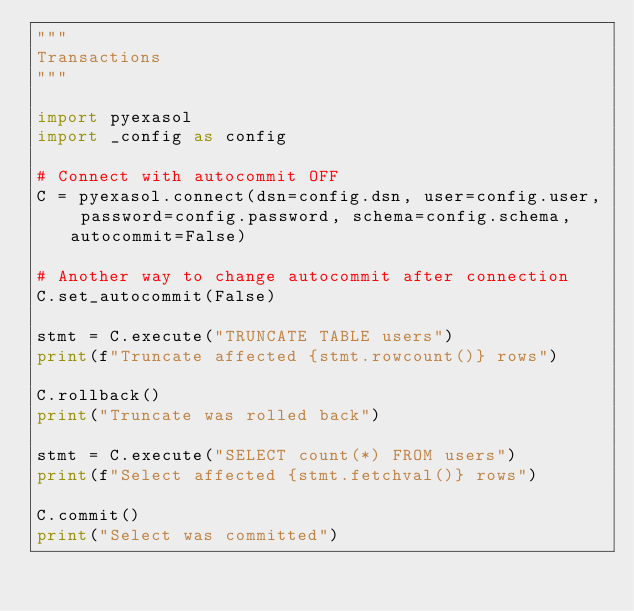Convert code to text. <code><loc_0><loc_0><loc_500><loc_500><_Python_>"""
Transactions
"""

import pyexasol
import _config as config

# Connect with autocommit OFF
C = pyexasol.connect(dsn=config.dsn, user=config.user, password=config.password, schema=config.schema, autocommit=False)

# Another way to change autocommit after connection
C.set_autocommit(False)

stmt = C.execute("TRUNCATE TABLE users")
print(f"Truncate affected {stmt.rowcount()} rows")

C.rollback()
print("Truncate was rolled back")

stmt = C.execute("SELECT count(*) FROM users")
print(f"Select affected {stmt.fetchval()} rows")

C.commit()
print("Select was committed")
</code> 